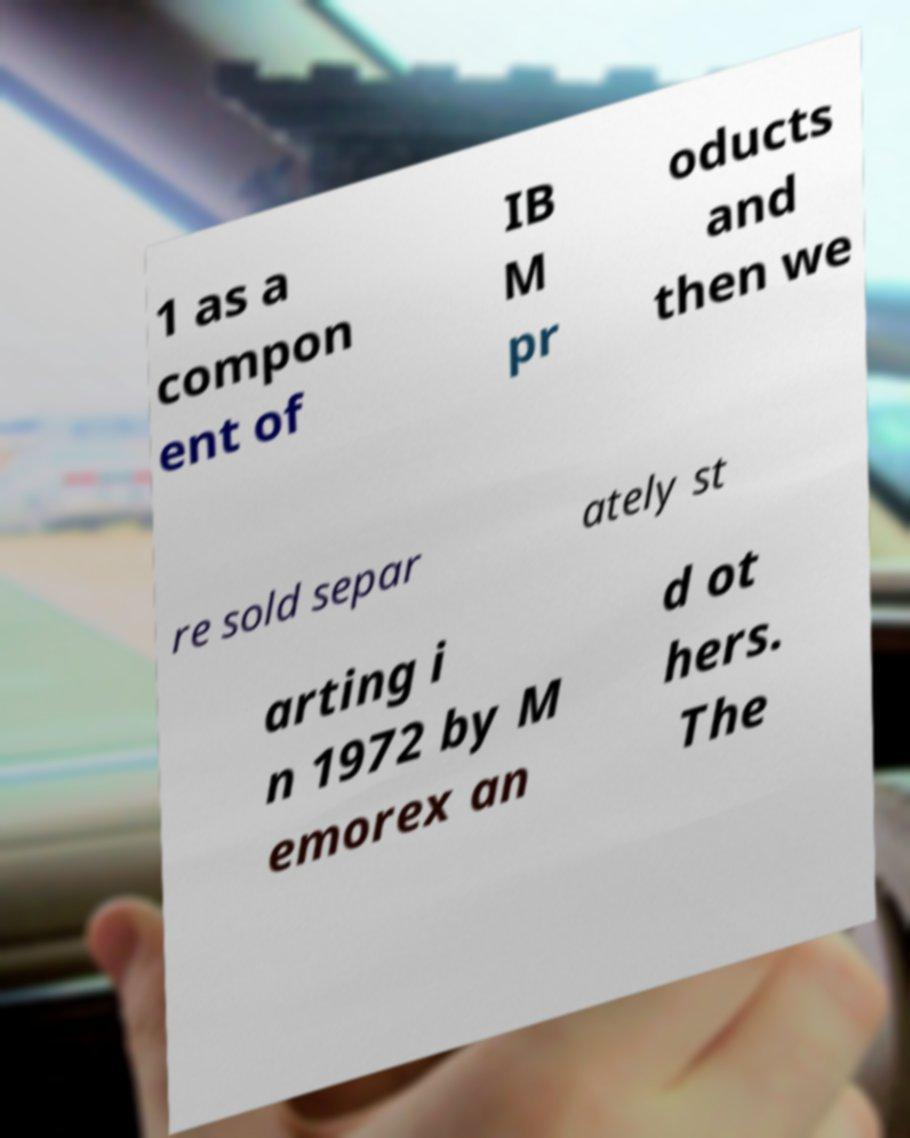Can you read and provide the text displayed in the image?This photo seems to have some interesting text. Can you extract and type it out for me? 1 as a compon ent of IB M pr oducts and then we re sold separ ately st arting i n 1972 by M emorex an d ot hers. The 